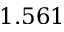Convert formula to latex. <formula><loc_0><loc_0><loc_500><loc_500>1 . 5 6 1</formula> 